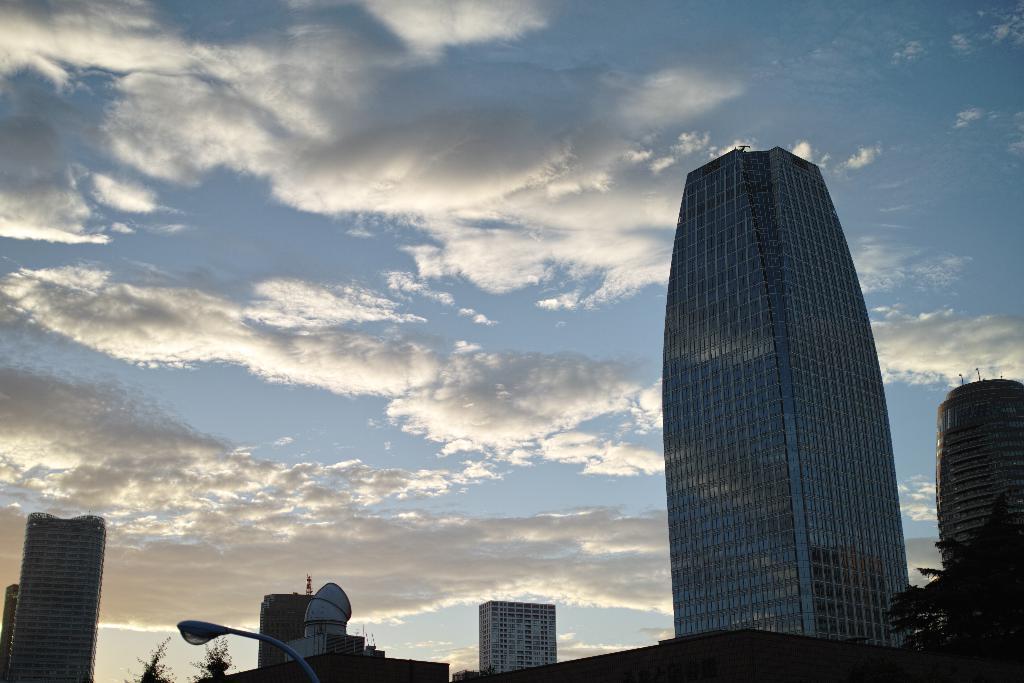Could you give a brief overview of what you see in this image? In this picture we can see buildings, trees, light and in the background we can see the sky with clouds. 